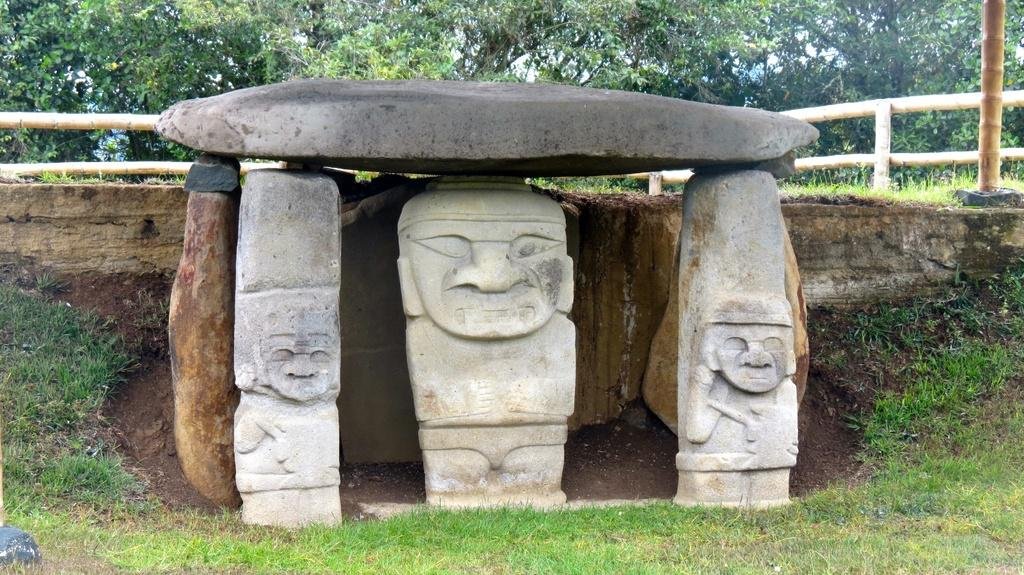What type of objects can be seen in the image? There are carving stones in the image. What is the natural environment like in the image? There is grass in the image, and trees can be seen in the background. What architectural feature is visible in the background of the image? There is a wooden fence in the background of the image. What type of test is being conducted on the crate in the image? There is no crate present in the image, and therefore no test is being conducted. What scientific experiment can be observed in the image? There is no scientific experiment visible in the image. 